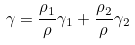<formula> <loc_0><loc_0><loc_500><loc_500>\gamma = \frac { \rho _ { 1 } } { \rho } \gamma _ { 1 } + \frac { \rho _ { 2 } } { \rho } \gamma _ { 2 }</formula> 